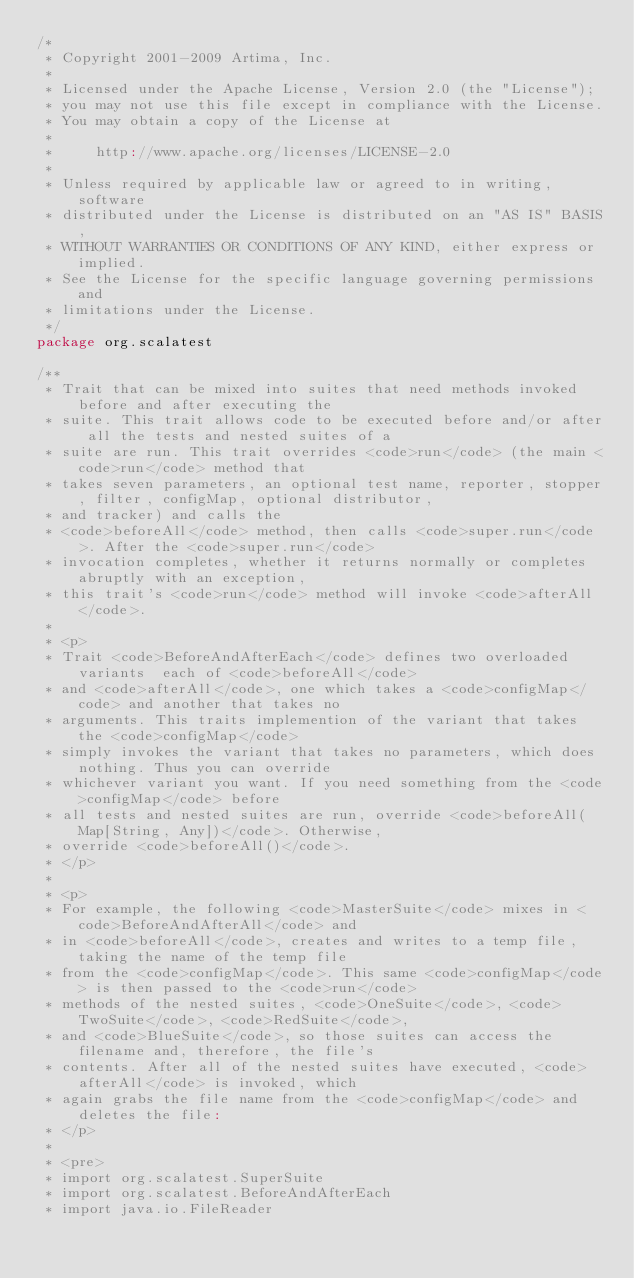<code> <loc_0><loc_0><loc_500><loc_500><_Scala_>/*
 * Copyright 2001-2009 Artima, Inc.
 *
 * Licensed under the Apache License, Version 2.0 (the "License");
 * you may not use this file except in compliance with the License.
 * You may obtain a copy of the License at
 *
 *     http://www.apache.org/licenses/LICENSE-2.0
 *
 * Unless required by applicable law or agreed to in writing, software
 * distributed under the License is distributed on an "AS IS" BASIS,
 * WITHOUT WARRANTIES OR CONDITIONS OF ANY KIND, either express or implied.
 * See the License for the specific language governing permissions and
 * limitations under the License.
 */
package org.scalatest

/**
 * Trait that can be mixed into suites that need methods invoked before and after executing the
 * suite. This trait allows code to be executed before and/or after all the tests and nested suites of a
 * suite are run. This trait overrides <code>run</code> (the main <code>run</code> method that
 * takes seven parameters, an optional test name, reporter, stopper, filter, configMap, optional distributor,
 * and tracker) and calls the
 * <code>beforeAll</code> method, then calls <code>super.run</code>. After the <code>super.run</code>
 * invocation completes, whether it returns normally or completes abruptly with an exception,
 * this trait's <code>run</code> method will invoke <code>afterAll</code>.
 *
 * <p>
 * Trait <code>BeforeAndAfterEach</code> defines two overloaded variants  each of <code>beforeAll</code>
 * and <code>afterAll</code>, one which takes a <code>configMap</code> and another that takes no
 * arguments. This traits implemention of the variant that takes the <code>configMap</code>
 * simply invokes the variant that takes no parameters, which does nothing. Thus you can override
 * whichever variant you want. If you need something from the <code>configMap</code> before
 * all tests and nested suites are run, override <code>beforeAll(Map[String, Any])</code>. Otherwise,
 * override <code>beforeAll()</code>.
 * </p>
 *
 * <p>
 * For example, the following <code>MasterSuite</code> mixes in <code>BeforeAndAfterAll</code> and
 * in <code>beforeAll</code>, creates and writes to a temp file, taking the name of the temp file
 * from the <code>configMap</code>. This same <code>configMap</code> is then passed to the <code>run</code>
 * methods of the nested suites, <code>OneSuite</code>, <code>TwoSuite</code>, <code>RedSuite</code>,
 * and <code>BlueSuite</code>, so those suites can access the filename and, therefore, the file's
 * contents. After all of the nested suites have executed, <code>afterAll</code> is invoked, which
 * again grabs the file name from the <code>configMap</code> and deletes the file:
 * </p>
 * 
 * <pre>
 * import org.scalatest.SuperSuite
 * import org.scalatest.BeforeAndAfterEach
 * import java.io.FileReader</code> 